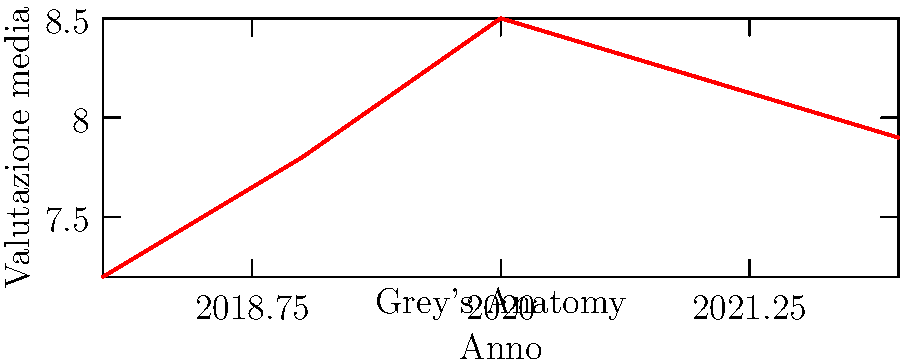Analizzando il grafico delle valutazioni medie annuali di "Grey's Anatomy", qual è stata la variazione percentuale della valutazione tra il picco nel 2020 e l'ultimo dato disponibile nel 2022? Per risolvere questo problema, seguiamo questi passaggi:

1. Identifichiamo il picco nel 2020: 8.5
2. Troviamo l'ultimo dato disponibile nel 2022: 7.9
3. Calcoliamo la differenza: 8.5 - 7.9 = 0.6
4. Calcoliamo la variazione percentuale:
   $\frac{\text{Differenza}}{\text{Valore iniziale}} \times 100 = \frac{0.6}{8.5} \times 100$
5. Effettuiamo il calcolo:
   $\frac{0.6}{8.5} \times 100 \approx 0.0706 \times 100 \approx 7.06\%$

Quindi, la variazione percentuale della valutazione tra il picco nel 2020 e l'ultimo dato disponibile nel 2022 è stata una diminuzione di circa il 7.06%.
Answer: -7.06% 